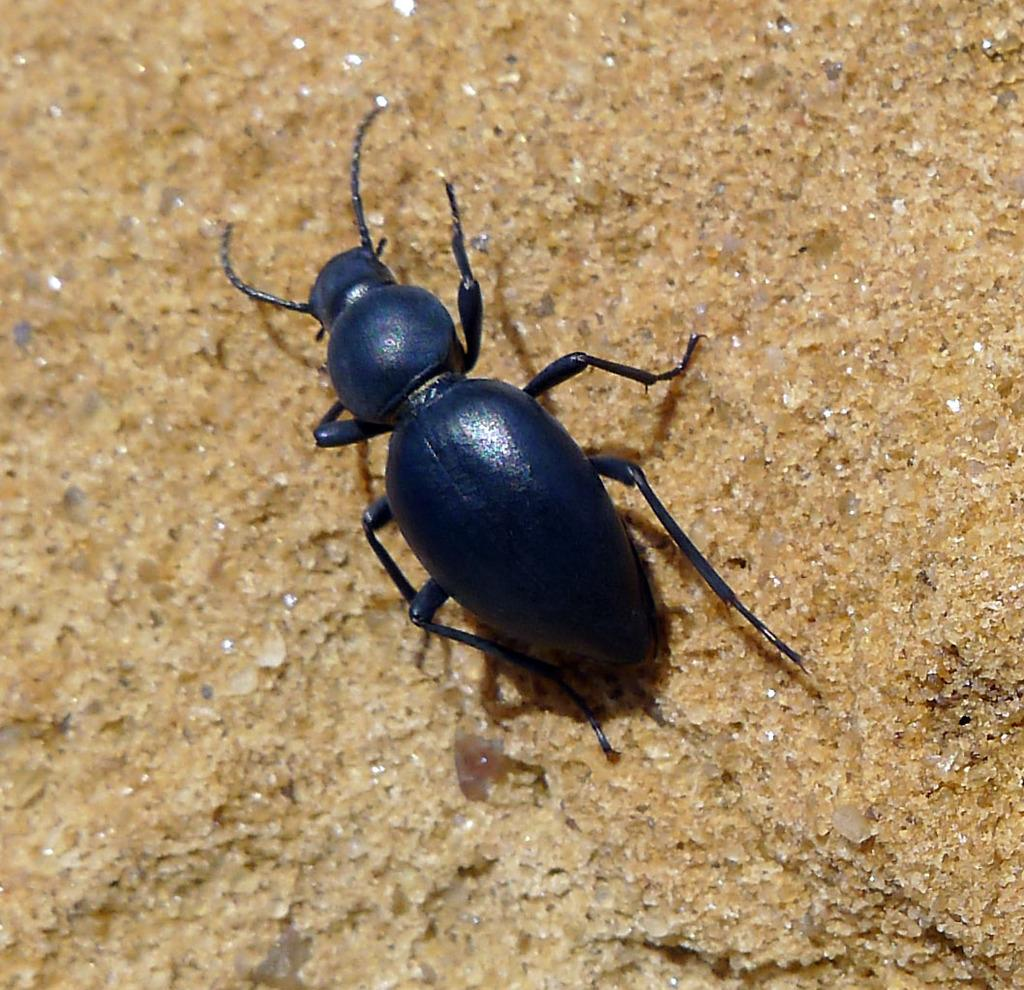What type of creature can be seen in the image? There is an insect in the image. What is the insect standing on or near? The insect is on a brown color platform. What type of pin is the uncle wearing in the image? There is no uncle or pin present in the image; it only features an insect on a brown color platform. Can you see a pig in the image? There is no pig present in the image; it only features an insect on a brown color platform. 